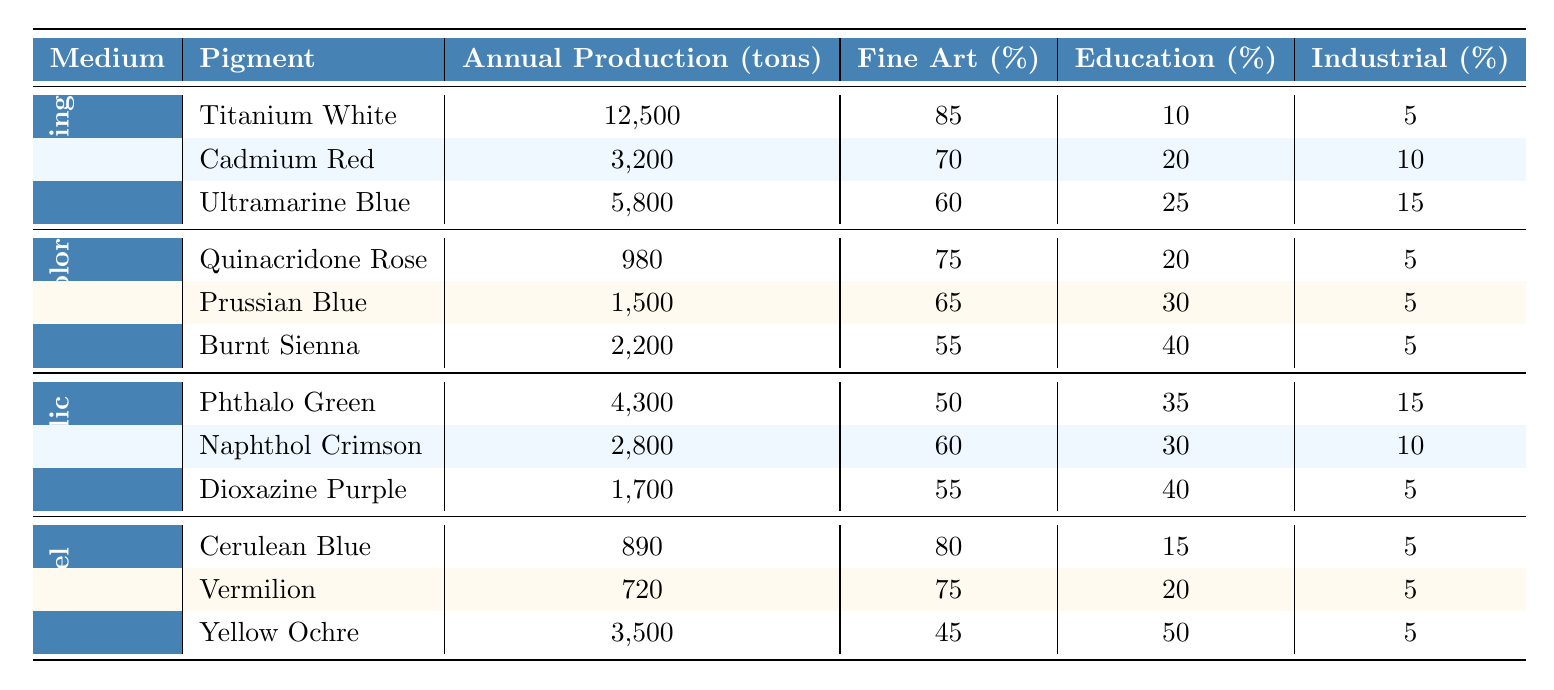What is the annual production of Titanium White? The table lists the annual production values for different pigments under oil painting. Titanium White has an annual production of 12,500 tons.
Answer: 12,500 tons Which medium has the highest annual production of pigments? To find this, I will sum the annual productions for all pigments under each medium: Oil Painting (12,500 + 3,200 + 5,800), Watercolor (980 + 1,500 + 2,200), Acrylic (4,300 + 2,800 + 1,700), and Pastel (890 + 720 + 3,500). The sum for Oil Painting is 21,500 tons, for Watercolor it's 4,680 tons, for Acrylic it's 8,800 tons, and for Pastel it's 5,110 tons. Hence, Oil Painting has the highest total production.
Answer: Oil Painting What percentage of Naphthol Crimson is used in fine art? The table indicates that 60% of Naphthol Crimson is used in fine art as per its listed usage in the Acrylic medium.
Answer: 60% True or false: The pigment Burnt Sienna has more usage in education than in fine art. According to the table, Burnt Sienna has 40% usage in education and 55% in fine art. Therefore, it is false that it has more usage in education than fine art.
Answer: False What is the total annual production of pigments used in Pastel? The total for Pastel pigments is calculated by adding: Cerulean Blue (890 tons) + Vermilion (720 tons) + Yellow Ochre (3,500 tons) = 890 + 720 + 3,500 = 5,110 tons.
Answer: 5,110 tons Which color pigment in Watercolor has the highest percentage usage in fine art? By comparing the fine art usage percentages listed for the Watercolor pigments: Quinacridone Rose (75%), Prussian Blue (65%), and Burnt Sienna (55%). Quinacridone Rose has the highest fine art usage at 75%.
Answer: Quinacridone Rose If we consider the total production of oil painting pigments, what is the percentage of Cadmium Red's production compared to the total? The total production for oil painting pigments is 12,500 + 3,200 + 5,800 = 21,500 tons. Cadmium Red's production is 3,200 tons. To find the percentage: (3,200 / 21,500) * 100 = 14.88%.
Answer: 14.88% What is the average percentage of industrial application usage across all painting mediums? I'll sum the industrial application usage for each pigment: Oil Painting (5% + 10% + 15% = 30%), Watercolor (5% + 5% + 5% = 15%), Acrylic (15% + 10% + 5% = 30%), and Pastel (5% + 5% + 5% = 15%). The total percentage is 30 + 15 + 30 + 15 = 90%. There are 4 mediums, so the average is 90 / 4 = 22.5%.
Answer: 22.5% Which pigment has the lowest production in the Acrylic medium? Looking at the annual production values for the Acrylic pigments: Phthalo Green (4,300 tons), Naphthol Crimson (2,800 tons), and Dioxazine Purple (1,700 tons). Dioxazine Purple has the lowest production at 1,700 tons.
Answer: Dioxazine Purple How much total production of pigments is used in education across all mediums? I will sum the education usage contributions for all pigments: Oil Painting (10% of 12,500 + 20% of 3,200 + 25% of 5,800), Watercolor (20% of 980 + 30% of 1,500 + 40% of 2,200), Acrylic (35% of 4,300 + 30% of 2,800 + 40% of 1,700), and Pastel (15% of 890 + 20% of 720 + 50% of 3,500). Calculating these, I find the total for education usage contributions amounts to 1,250 + 640 + 1,450 + 196 + 450 + 0 + 850 + 360 + 1,750 = 7,646 tons when simplified.
Answer: 7,646 tons 